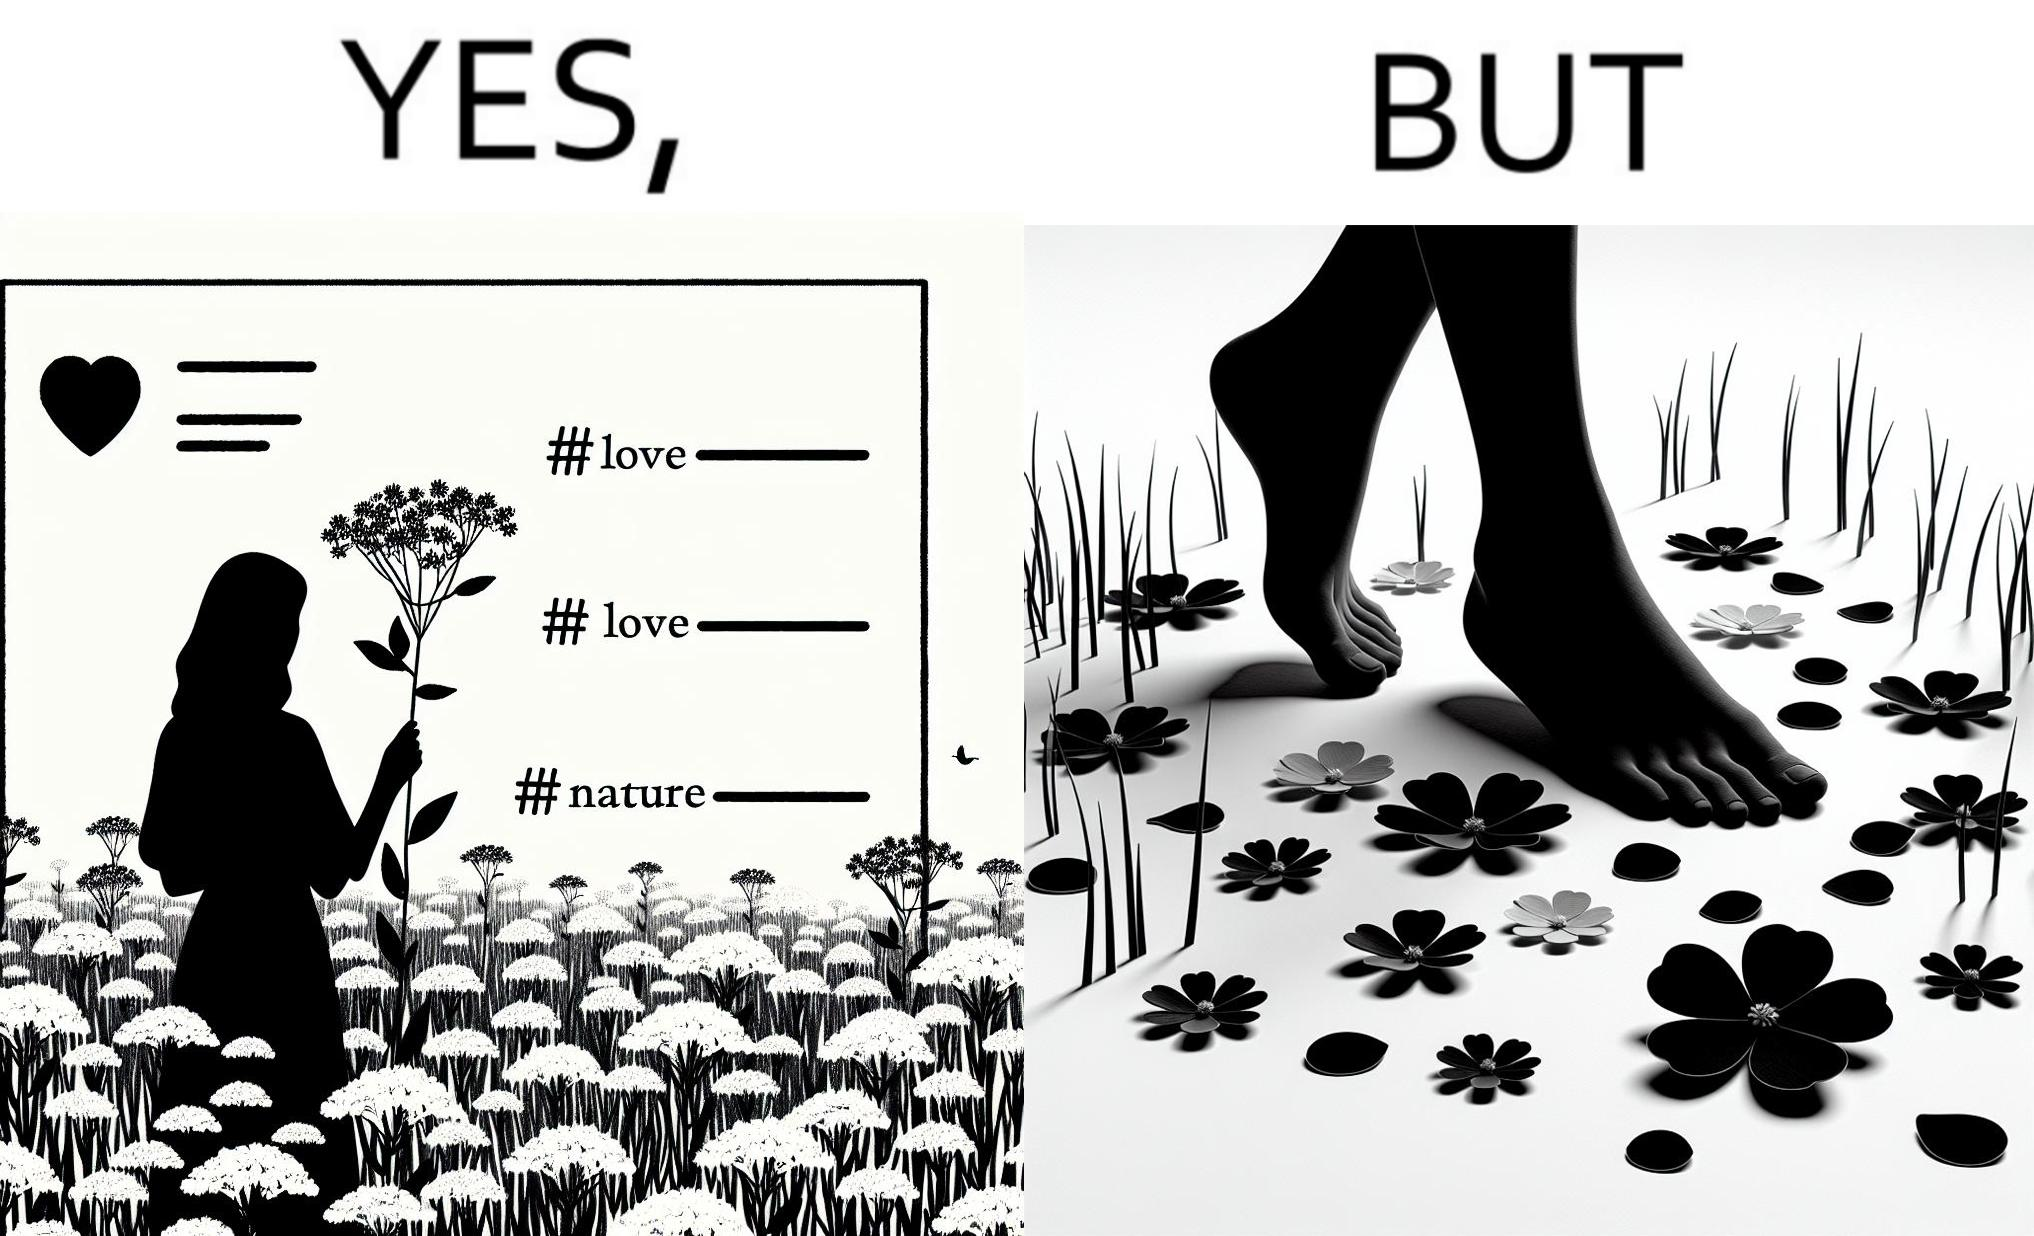Does this image contain satire or humor? Yes, this image is satirical. 